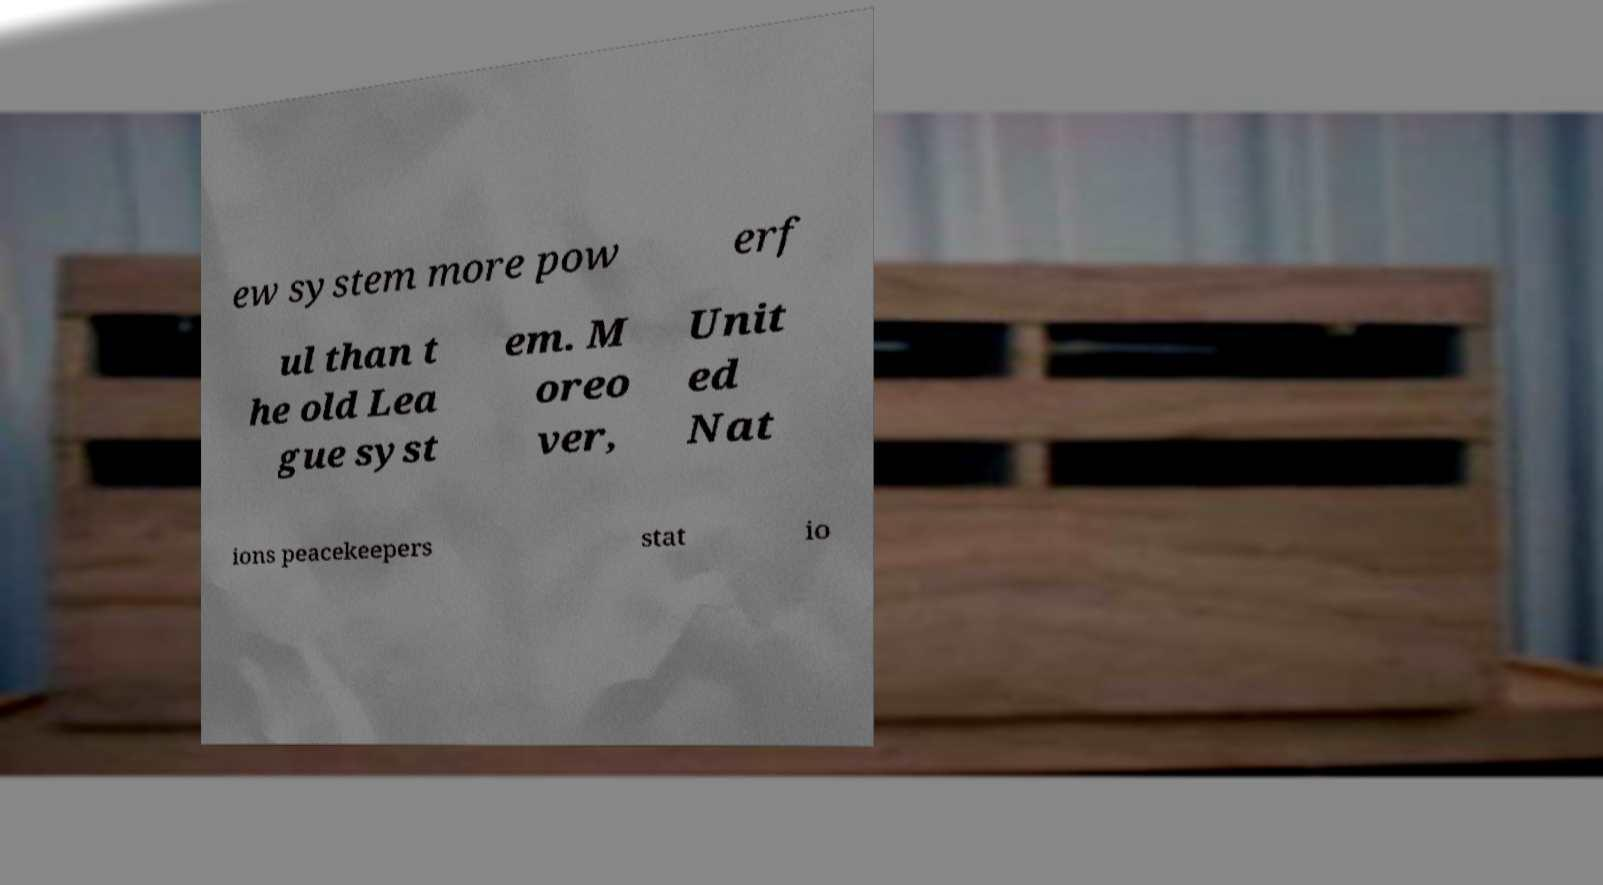Please identify and transcribe the text found in this image. ew system more pow erf ul than t he old Lea gue syst em. M oreo ver, Unit ed Nat ions peacekeepers stat io 